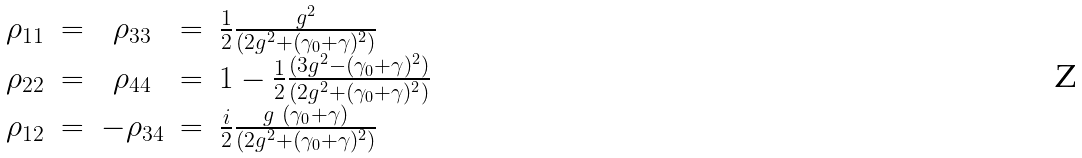<formula> <loc_0><loc_0><loc_500><loc_500>\begin{array} { c c c c l } \rho _ { 1 1 } & = & \rho _ { 3 3 } & = & \frac { 1 } { 2 } \frac { g ^ { 2 } } { ( 2 g ^ { 2 } + ( \gamma _ { 0 } + \gamma ) ^ { 2 } ) } \\ \rho _ { 2 2 } & = & \rho _ { 4 4 } & = & 1 - \frac { 1 } { 2 } \frac { ( 3 g ^ { 2 } - ( \gamma _ { 0 } + \gamma ) ^ { 2 } ) } { ( 2 g ^ { 2 } + ( \gamma _ { 0 } + \gamma ) ^ { 2 } ) } \\ \rho _ { 1 2 } & = & - \rho _ { 3 4 } & = & \frac { i } { 2 } \frac { g \ ( \gamma _ { 0 } + \gamma ) } { ( 2 g ^ { 2 } + ( \gamma _ { 0 } + \gamma ) ^ { 2 } ) } \\ \end{array}</formula> 